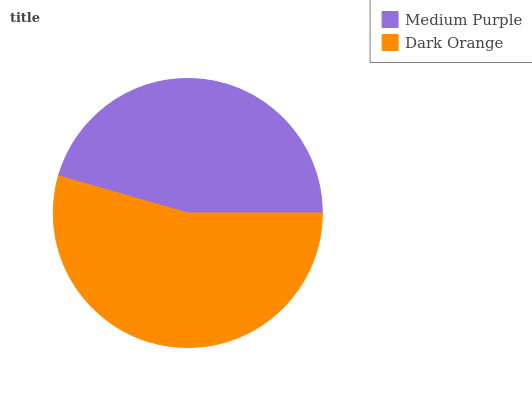Is Medium Purple the minimum?
Answer yes or no. Yes. Is Dark Orange the maximum?
Answer yes or no. Yes. Is Dark Orange the minimum?
Answer yes or no. No. Is Dark Orange greater than Medium Purple?
Answer yes or no. Yes. Is Medium Purple less than Dark Orange?
Answer yes or no. Yes. Is Medium Purple greater than Dark Orange?
Answer yes or no. No. Is Dark Orange less than Medium Purple?
Answer yes or no. No. Is Dark Orange the high median?
Answer yes or no. Yes. Is Medium Purple the low median?
Answer yes or no. Yes. Is Medium Purple the high median?
Answer yes or no. No. Is Dark Orange the low median?
Answer yes or no. No. 